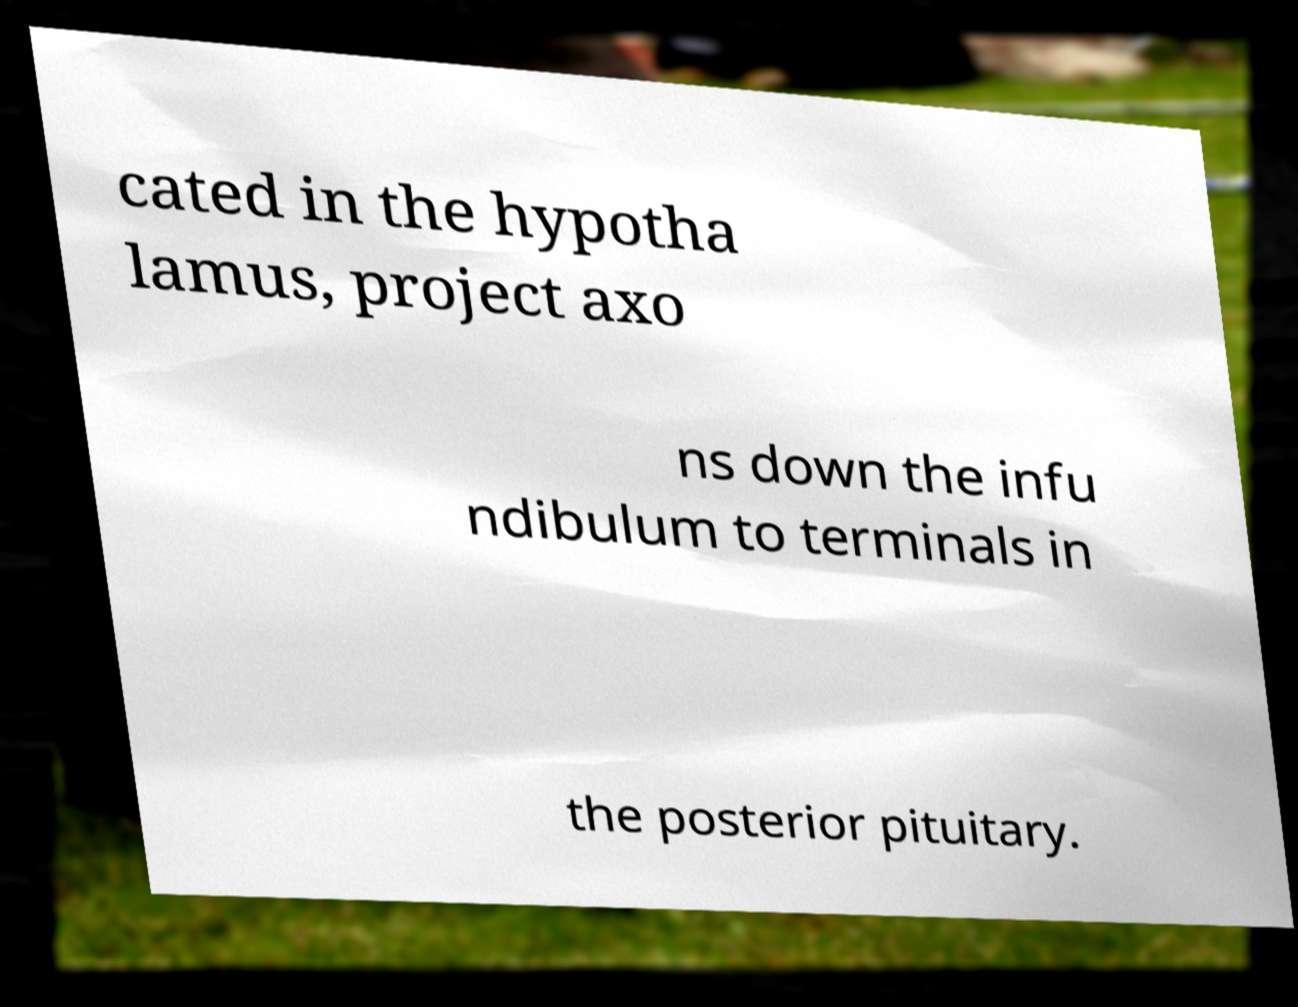There's text embedded in this image that I need extracted. Can you transcribe it verbatim? cated in the hypotha lamus, project axo ns down the infu ndibulum to terminals in the posterior pituitary. 